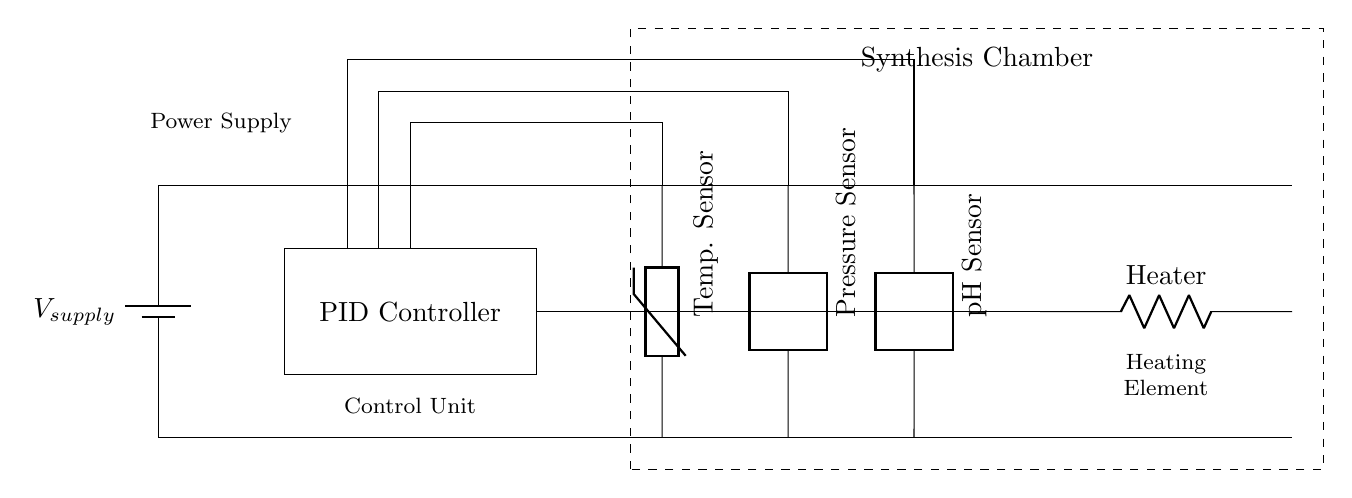What is the component that regulates temperature? The PID controller is responsible for regulating temperature in this circuit. It adjusts the heating element based on input from temperature, pressure, and pH sensors to maintain the desired conditions in the synthesis chamber.
Answer: PID controller What type of sensor measures pressure? The circuit includes a two-port device labeled as a pressure sensor, which is designed to measure the pressure variable in the synthesis chamber.
Answer: Pressure sensor How many sensors are integrated into the chamber system? There are three sensors depicted in the diagram: a temperature sensor, a pressure sensor, and a pH sensor, all contributing data for the PID control system.
Answer: Three What is the main purpose of the heating element? The heating element is used to maintain the temperature conditions required for the synthesis process, as dictated by the PID controller based on sensor inputs.
Answer: Maintain temperature What is the role of the power supply in this circuit? The power supply provides the necessary voltage for the entire circuit operation, powering all components including the PID controller and heating element.
Answer: Provides voltage How does the PID controller interact with the temperature sensor? The PID controller takes input from the temperature sensor to continuously adjust the output to the heating element, ensuring the temperature remains at the set point. This requires reasoning through understanding sensor feedback loops and control mechanisms.
Answer: Adjusts heating element 